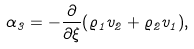<formula> <loc_0><loc_0><loc_500><loc_500>\alpha _ { 3 } = - { \frac { \partial } { \partial \xi } } { \left ( \varrho _ { 1 } v _ { 2 } + \varrho _ { 2 } v _ { 1 } \right ) } ,</formula> 